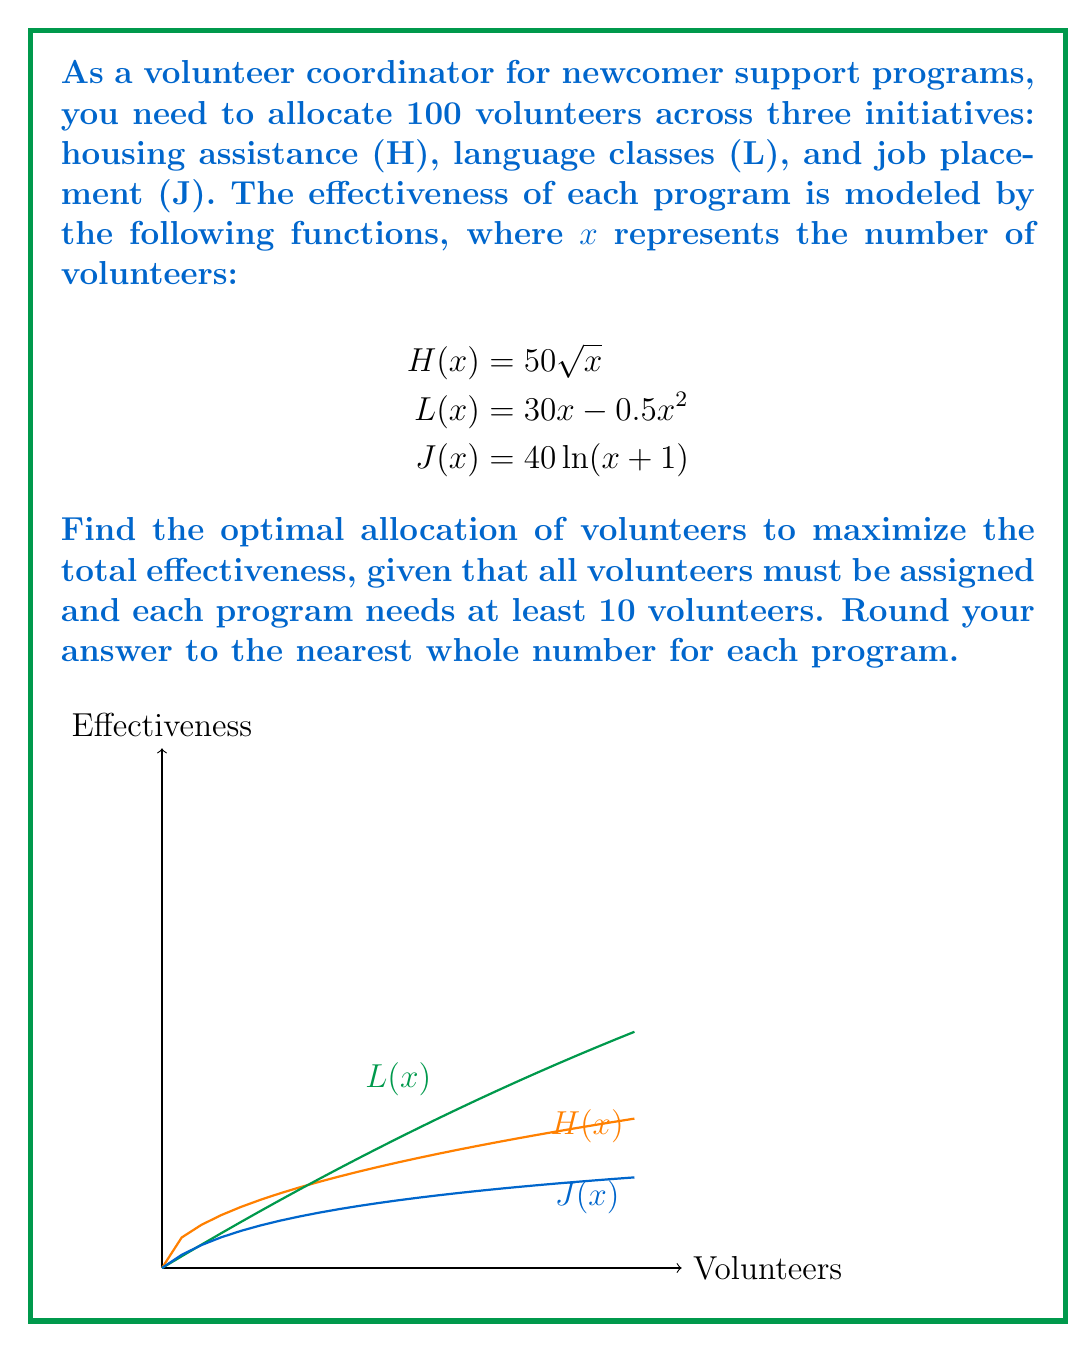Can you solve this math problem? To solve this optimization problem, we'll use the method of Lagrange multipliers with inequality constraints (Karush-Kuhn-Tucker conditions).

Step 1: Define the objective function and constraints
Let $x_1$, $x_2$, and $x_3$ be the number of volunteers for H, L, and J respectively.
Objective function: $f(x_1,x_2,x_3) = 50\sqrt{x_1} + 30x_2 - 0.5x_2^2 + 40\ln(x_3+1)$
Constraints:
$g_1(x_1,x_2,x_3) = x_1 + x_2 + x_3 - 100 = 0$
$x_1 \geq 10$, $x_2 \geq 10$, $x_3 \geq 10$

Step 2: Write the Lagrangian function
$L = f(x_1,x_2,x_3) - \lambda g_1(x_1,x_2,x_3) + \mu_1(x_1-10) + \mu_2(x_2-10) + \mu_3(x_3-10)$

Step 3: Apply KKT conditions
$\frac{\partial L}{\partial x_1} = \frac{25}{\sqrt{x_1}} - \lambda + \mu_1 = 0$
$\frac{\partial L}{\partial x_2} = 30 - x_2 - \lambda + \mu_2 = 0$
$\frac{\partial L}{\partial x_3} = \frac{40}{x_3+1} - \lambda + \mu_3 = 0$
$\frac{\partial L}{\partial \lambda} = x_1 + x_2 + x_3 - 100 = 0$
$\mu_1(x_1-10) = 0$, $\mu_2(x_2-10) = 0$, $\mu_3(x_3-10) = 0$
$\mu_1 \geq 0$, $\mu_2 \geq 0$, $\mu_3 \geq 0$

Step 4: Solve the system of equations
From the KKT conditions, we can deduce that at the optimal point, the marginal effectiveness of each program should be equal (if not constrained by the minimum requirement). This gives us:

$\frac{25}{\sqrt{x_1}} = 30 - x_2 = \frac{40}{x_3+1}$

Solving this system numerically along with the constraint $x_1 + x_2 + x_3 = 100$ yields:
$x_1 \approx 39.06$, $x_2 \approx 30.94$, $x_3 \approx 30.00$

Step 5: Check and adjust for minimum requirements
All values are above the minimum requirement of 10, so no adjustment is needed.

Step 6: Round to the nearest whole number
$x_1 = 39$, $x_2 = 31$, $x_3 = 30$
Answer: Housing: 39, Language: 31, Job: 30 